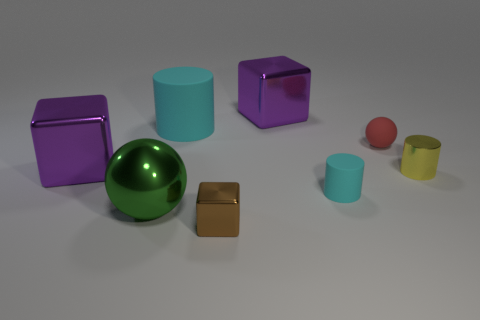Is there anything in the image that suggests motion? The image itself is a still render without any explicit indications of motion. However, the arrangement of the objects with varying distances and positions may give a subtle impression of potential movement, as though the objects could have been in motion before coming to rest. 